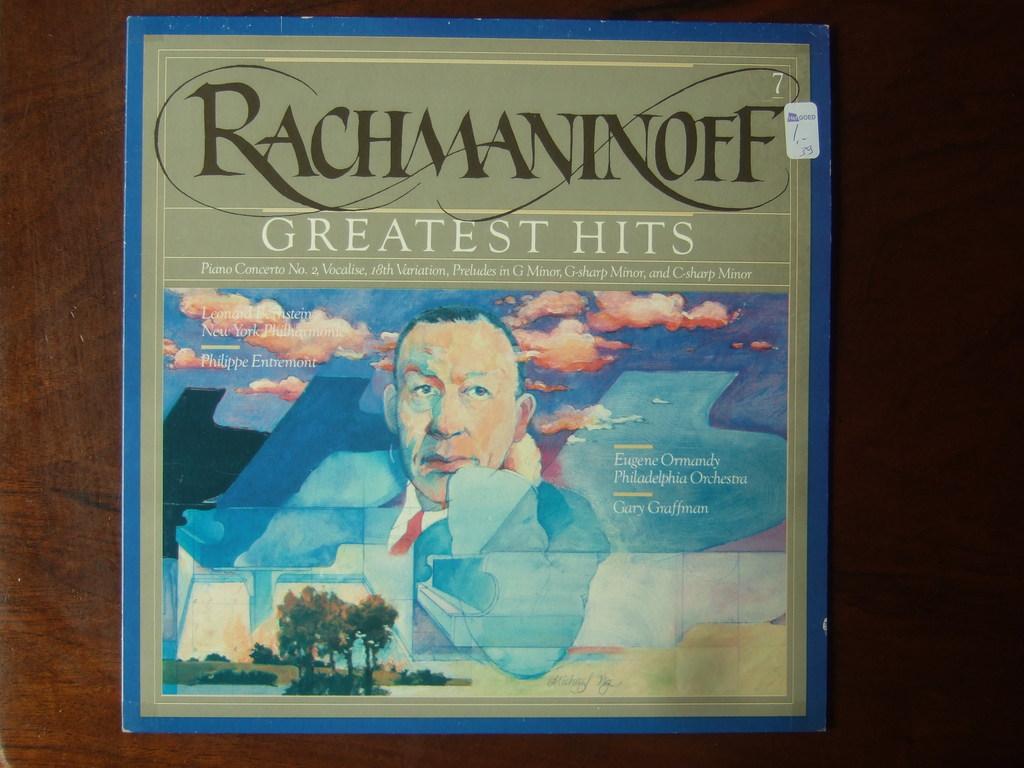Who performed the music for the album?
Ensure brevity in your answer.  Rachmaninoff. 